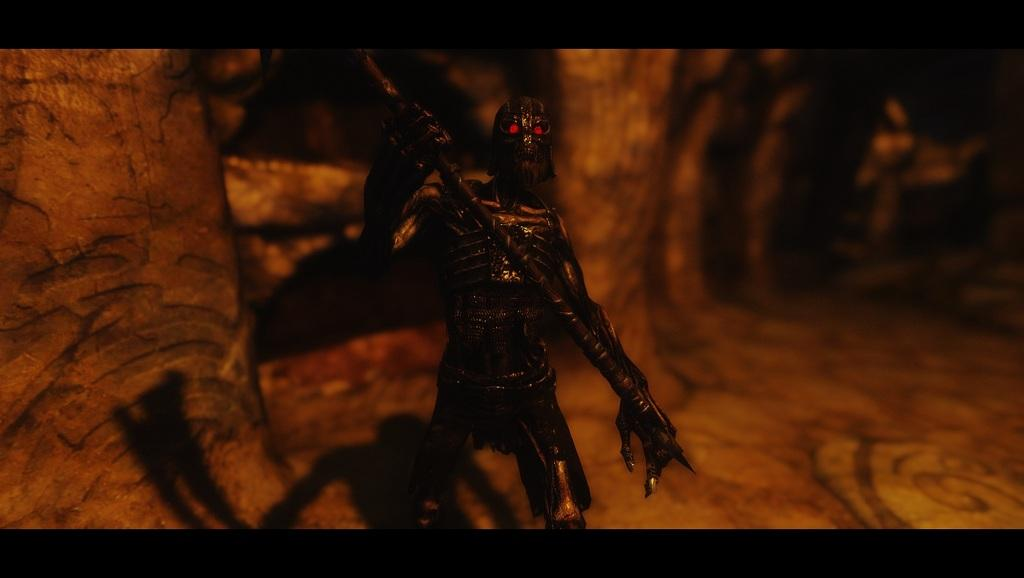What type of image is being described? The image is animated. What can be seen in the animated image? There is an animated character in the image. What is the animated character holding? The animated character is holding a rod. What type of jelly is the animated character eating in the image? There is no jelly present in the image, and the animated character is not eating anything. What type of work does the secretary do in the image? There is no secretary present in the image. 